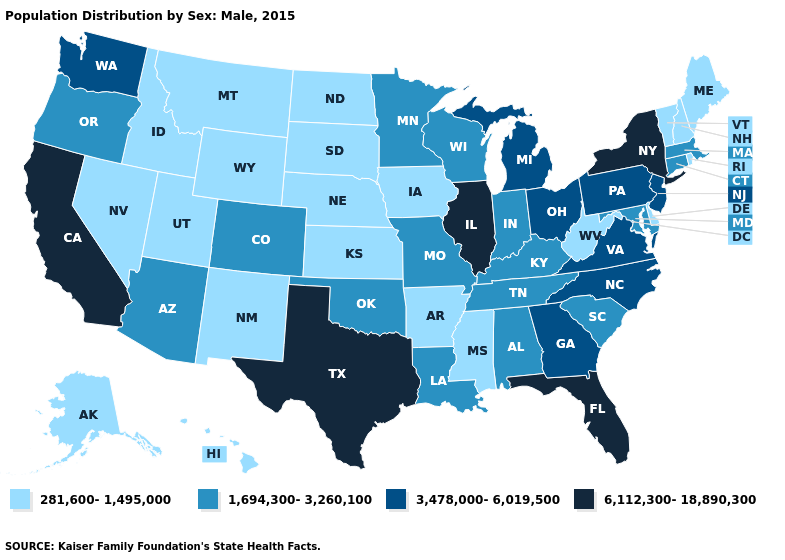What is the value of Illinois?
Answer briefly. 6,112,300-18,890,300. Name the states that have a value in the range 1,694,300-3,260,100?
Answer briefly. Alabama, Arizona, Colorado, Connecticut, Indiana, Kentucky, Louisiana, Maryland, Massachusetts, Minnesota, Missouri, Oklahoma, Oregon, South Carolina, Tennessee, Wisconsin. What is the value of Minnesota?
Give a very brief answer. 1,694,300-3,260,100. What is the value of Arizona?
Concise answer only. 1,694,300-3,260,100. Does Wyoming have the same value as Nebraska?
Keep it brief. Yes. Does Kentucky have the same value as Vermont?
Keep it brief. No. Does California have the lowest value in the West?
Quick response, please. No. Does Michigan have a higher value than Texas?
Be succinct. No. Name the states that have a value in the range 281,600-1,495,000?
Give a very brief answer. Alaska, Arkansas, Delaware, Hawaii, Idaho, Iowa, Kansas, Maine, Mississippi, Montana, Nebraska, Nevada, New Hampshire, New Mexico, North Dakota, Rhode Island, South Dakota, Utah, Vermont, West Virginia, Wyoming. Name the states that have a value in the range 281,600-1,495,000?
Short answer required. Alaska, Arkansas, Delaware, Hawaii, Idaho, Iowa, Kansas, Maine, Mississippi, Montana, Nebraska, Nevada, New Hampshire, New Mexico, North Dakota, Rhode Island, South Dakota, Utah, Vermont, West Virginia, Wyoming. Does the map have missing data?
Short answer required. No. Among the states that border South Carolina , which have the highest value?
Answer briefly. Georgia, North Carolina. Which states have the highest value in the USA?
Keep it brief. California, Florida, Illinois, New York, Texas. What is the value of Delaware?
Be succinct. 281,600-1,495,000. Which states have the lowest value in the Northeast?
Short answer required. Maine, New Hampshire, Rhode Island, Vermont. 